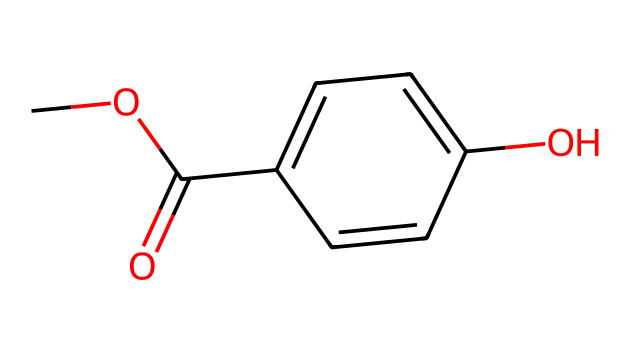What is the molecular formula of methylparaben? The molecular formula can be derived from the arrangement of atoms in the chemical structure. Counting the carbon (C), hydrogen (H), and oxygen (O) atoms results in C8H8O3.
Answer: C8H8O3 How many carbon atoms are present in the chemical structure? By analyzing the structure, we can count the number of carbon atoms. The methyl, carbonyl, and aromatic ring components contribute a total of eight carbon atoms.
Answer: 8 What type of functional groups are present in methylparaben? Methylparaben contains an ester group (from the methoxy and carboxylic acid components) and a hydroxyl group (from the phenolic part of the structure).
Answer: ester, hydroxyl Which part of this chemical contributes to its preservative properties? The para-hydroxybenzoic acid component of methylparaben is known for its antimicrobial properties, inhibiting the growth of bacteria and fungi, contributing to its role as a preservative.
Answer: para-hydroxybenzoic acid What is the significance of the methoxy group in methylparaben? The methoxy group generally influences the solubility and stability of the compound, allowing methylparaben to be effective in aqueous formulations commonly found in personal care products.
Answer: solubility, stability What type of isomerism might exist within this chemical structure? This compound can exhibit structural isomerism, particularly since there are variations in the positions of functional groups on the carbon backbone, resulting in different para- or ortho-substituted phenols.
Answer: structural isomerism 